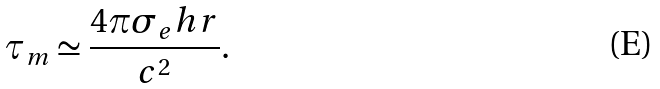Convert formula to latex. <formula><loc_0><loc_0><loc_500><loc_500>\tau _ { m } \simeq \frac { 4 \pi \sigma _ { e } h r } { c ^ { 2 } } .</formula> 